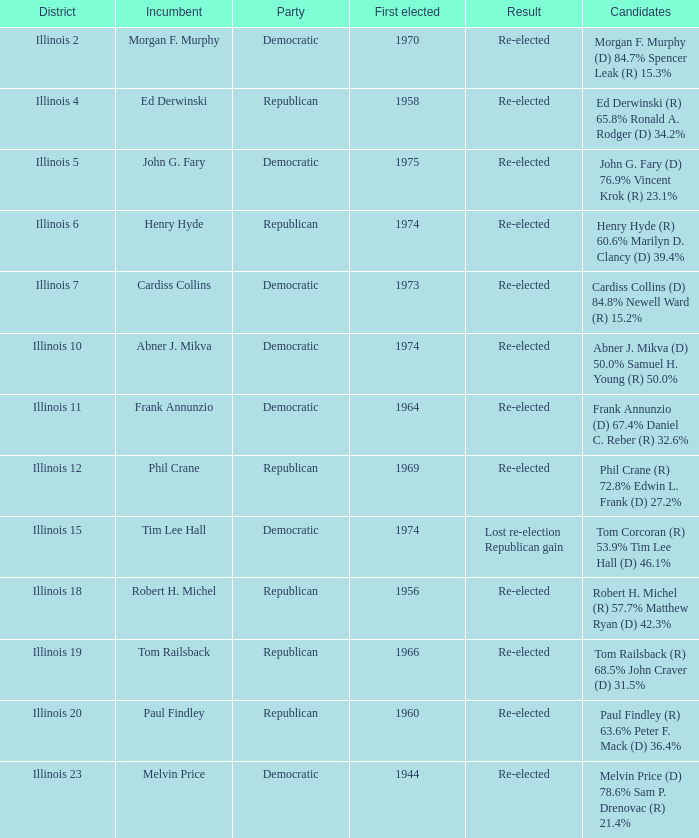Parse the table in full. {'header': ['District', 'Incumbent', 'Party', 'First elected', 'Result', 'Candidates'], 'rows': [['Illinois 2', 'Morgan F. Murphy', 'Democratic', '1970', 'Re-elected', 'Morgan F. Murphy (D) 84.7% Spencer Leak (R) 15.3%'], ['Illinois 4', 'Ed Derwinski', 'Republican', '1958', 'Re-elected', 'Ed Derwinski (R) 65.8% Ronald A. Rodger (D) 34.2%'], ['Illinois 5', 'John G. Fary', 'Democratic', '1975', 'Re-elected', 'John G. Fary (D) 76.9% Vincent Krok (R) 23.1%'], ['Illinois 6', 'Henry Hyde', 'Republican', '1974', 'Re-elected', 'Henry Hyde (R) 60.6% Marilyn D. Clancy (D) 39.4%'], ['Illinois 7', 'Cardiss Collins', 'Democratic', '1973', 'Re-elected', 'Cardiss Collins (D) 84.8% Newell Ward (R) 15.2%'], ['Illinois 10', 'Abner J. Mikva', 'Democratic', '1974', 'Re-elected', 'Abner J. Mikva (D) 50.0% Samuel H. Young (R) 50.0%'], ['Illinois 11', 'Frank Annunzio', 'Democratic', '1964', 'Re-elected', 'Frank Annunzio (D) 67.4% Daniel C. Reber (R) 32.6%'], ['Illinois 12', 'Phil Crane', 'Republican', '1969', 'Re-elected', 'Phil Crane (R) 72.8% Edwin L. Frank (D) 27.2%'], ['Illinois 15', 'Tim Lee Hall', 'Democratic', '1974', 'Lost re-election Republican gain', 'Tom Corcoran (R) 53.9% Tim Lee Hall (D) 46.1%'], ['Illinois 18', 'Robert H. Michel', 'Republican', '1956', 'Re-elected', 'Robert H. Michel (R) 57.7% Matthew Ryan (D) 42.3%'], ['Illinois 19', 'Tom Railsback', 'Republican', '1966', 'Re-elected', 'Tom Railsback (R) 68.5% John Craver (D) 31.5%'], ['Illinois 20', 'Paul Findley', 'Republican', '1960', 'Re-elected', 'Paul Findley (R) 63.6% Peter F. Mack (D) 36.4%'], ['Illinois 23', 'Melvin Price', 'Democratic', '1944', 'Re-elected', 'Melvin Price (D) 78.6% Sam P. Drenovac (R) 21.4%']]} What is the district for tim lee hall? Illinois 15. 